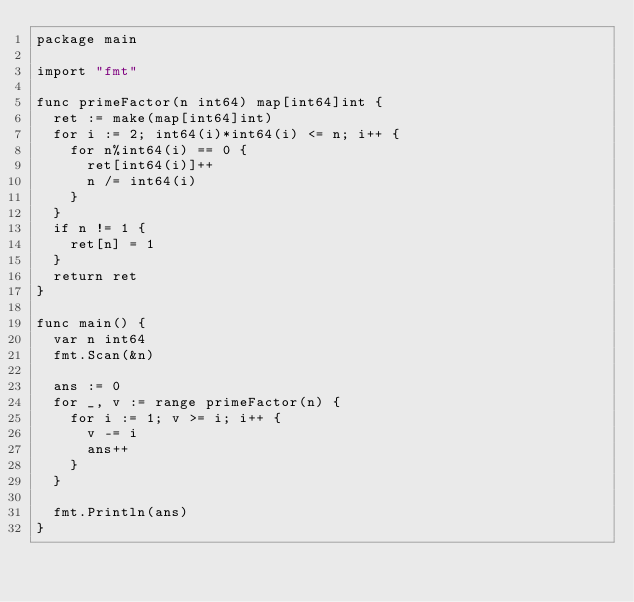Convert code to text. <code><loc_0><loc_0><loc_500><loc_500><_Go_>package main

import "fmt"

func primeFactor(n int64) map[int64]int {
	ret := make(map[int64]int)
	for i := 2; int64(i)*int64(i) <= n; i++ {
		for n%int64(i) == 0 {
			ret[int64(i)]++
			n /= int64(i)
		}
	}
	if n != 1 {
		ret[n] = 1
	}
	return ret
}

func main() {
	var n int64
	fmt.Scan(&n)

	ans := 0
	for _, v := range primeFactor(n) {
		for i := 1; v >= i; i++ {
			v -= i
			ans++
		}
	}

	fmt.Println(ans)
}
</code> 